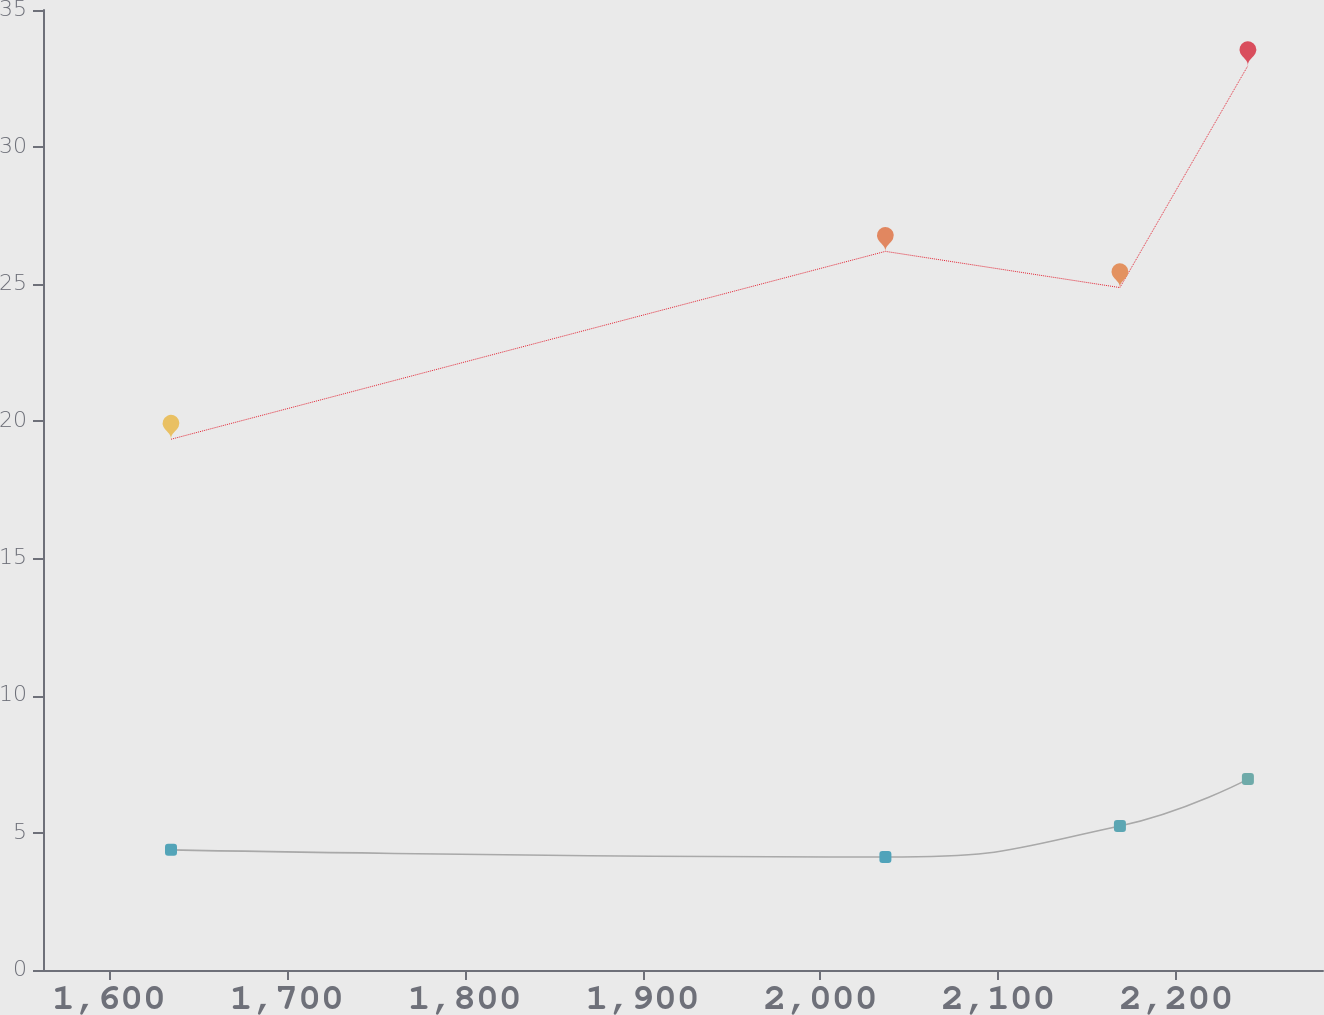Convert chart to OTSL. <chart><loc_0><loc_0><loc_500><loc_500><line_chart><ecel><fcel>Pension  Benefits<fcel>Postretirement Medical Benefits<nl><fcel>1634.92<fcel>19.35<fcel>4.38<nl><fcel>2036.52<fcel>26.2<fcel>4.12<nl><fcel>2168.35<fcel>24.88<fcel>5.25<nl><fcel>2240.3<fcel>32.97<fcel>6.96<nl><fcel>2354.47<fcel>31.64<fcel>6.7<nl></chart> 